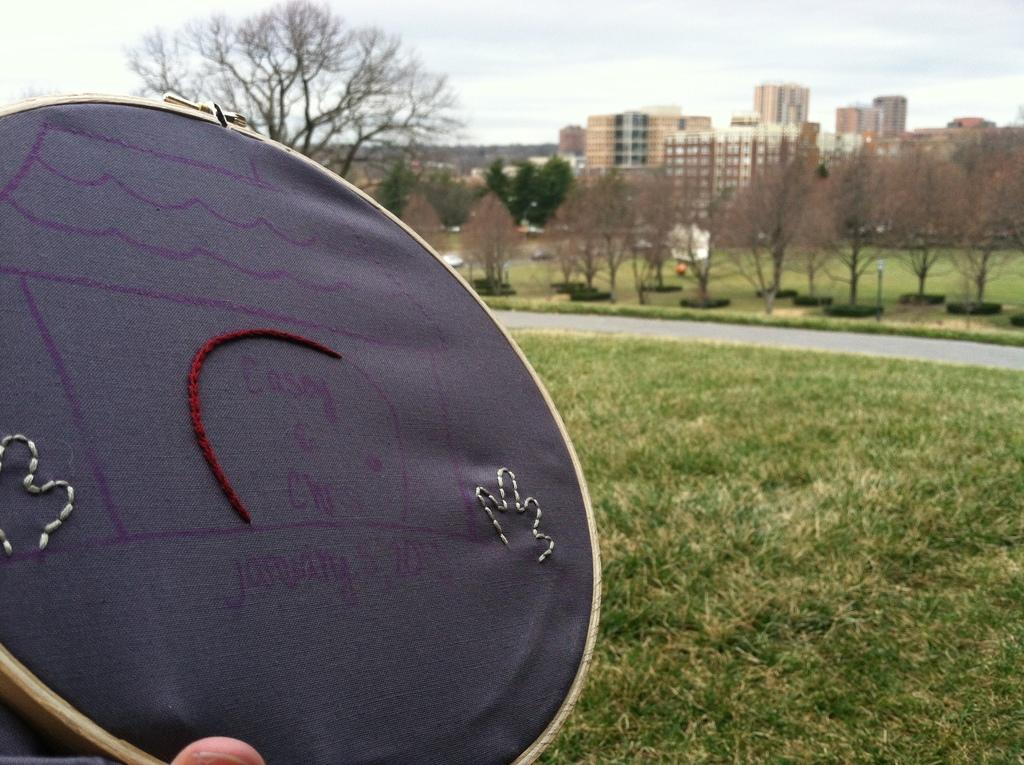Describe this image in one or two sentences. In the picture i can see an embroidered item and the cloth is of black color, on right side of the picture there are some trees, road, buildings and top of the picture there is clear sky. 